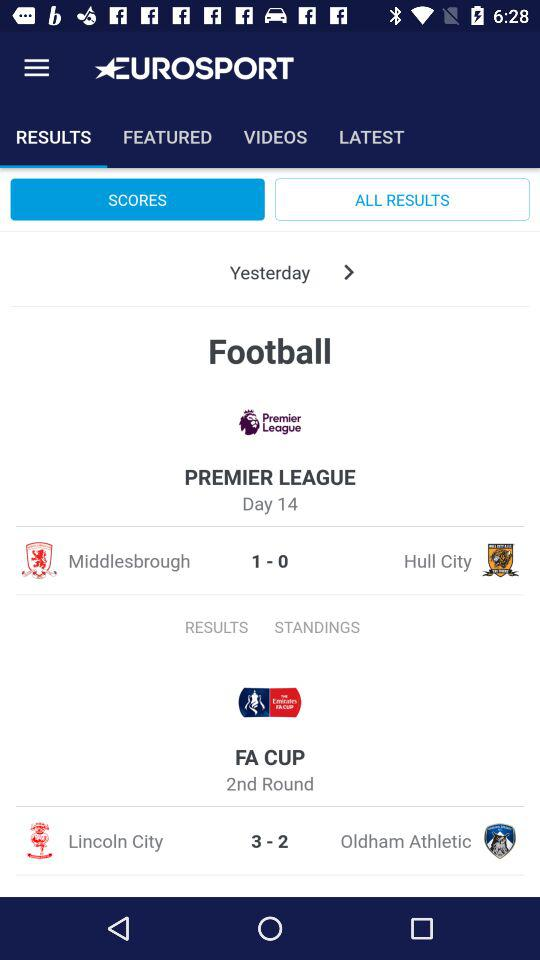How many more goals were scored in the Premier League than in the FA Cup?
Answer the question using a single word or phrase. 2 